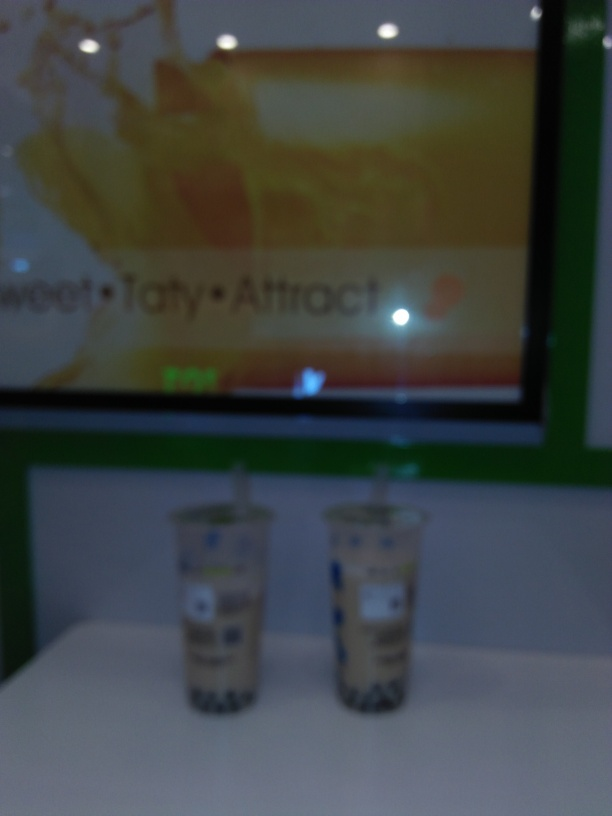Are the English letters in the image slightly blurry? Yes, the English letters displayed in the image are indeed slightly blurry, making it difficult to read the text clearly. This could be due to motion blur from the camera, an out-of-focus shot, or other photographic anomalies. 